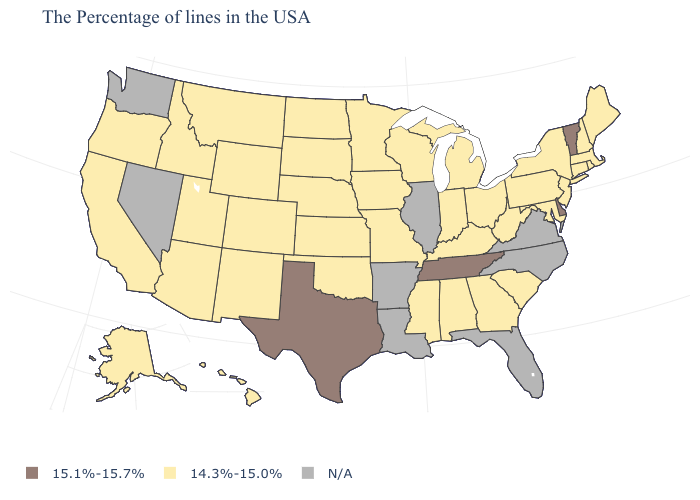Name the states that have a value in the range 14.3%-15.0%?
Write a very short answer. Maine, Massachusetts, Rhode Island, New Hampshire, Connecticut, New York, New Jersey, Maryland, Pennsylvania, South Carolina, West Virginia, Ohio, Georgia, Michigan, Kentucky, Indiana, Alabama, Wisconsin, Mississippi, Missouri, Minnesota, Iowa, Kansas, Nebraska, Oklahoma, South Dakota, North Dakota, Wyoming, Colorado, New Mexico, Utah, Montana, Arizona, Idaho, California, Oregon, Alaska, Hawaii. Is the legend a continuous bar?
Give a very brief answer. No. Name the states that have a value in the range 15.1%-15.7%?
Concise answer only. Vermont, Delaware, Tennessee, Texas. Which states have the lowest value in the MidWest?
Keep it brief. Ohio, Michigan, Indiana, Wisconsin, Missouri, Minnesota, Iowa, Kansas, Nebraska, South Dakota, North Dakota. How many symbols are there in the legend?
Short answer required. 3. What is the highest value in states that border Rhode Island?
Quick response, please. 14.3%-15.0%. Does the map have missing data?
Short answer required. Yes. What is the highest value in the South ?
Give a very brief answer. 15.1%-15.7%. What is the value of Connecticut?
Quick response, please. 14.3%-15.0%. Which states have the lowest value in the USA?
Keep it brief. Maine, Massachusetts, Rhode Island, New Hampshire, Connecticut, New York, New Jersey, Maryland, Pennsylvania, South Carolina, West Virginia, Ohio, Georgia, Michigan, Kentucky, Indiana, Alabama, Wisconsin, Mississippi, Missouri, Minnesota, Iowa, Kansas, Nebraska, Oklahoma, South Dakota, North Dakota, Wyoming, Colorado, New Mexico, Utah, Montana, Arizona, Idaho, California, Oregon, Alaska, Hawaii. What is the highest value in the USA?
Give a very brief answer. 15.1%-15.7%. What is the highest value in states that border Mississippi?
Short answer required. 15.1%-15.7%. How many symbols are there in the legend?
Give a very brief answer. 3. Does Vermont have the lowest value in the USA?
Answer briefly. No. Does the map have missing data?
Concise answer only. Yes. 